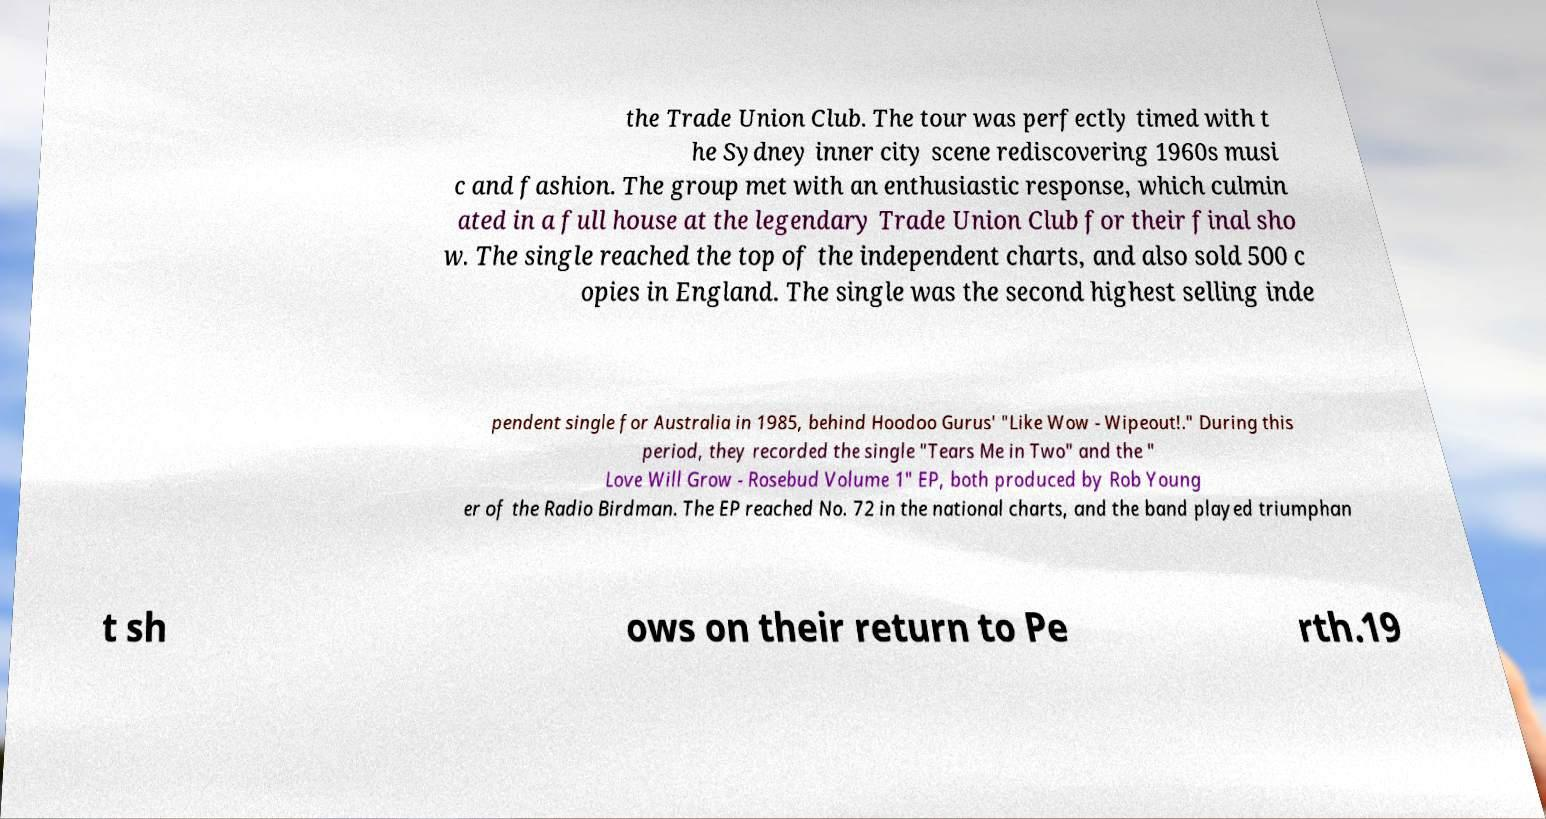Please identify and transcribe the text found in this image. the Trade Union Club. The tour was perfectly timed with t he Sydney inner city scene rediscovering 1960s musi c and fashion. The group met with an enthusiastic response, which culmin ated in a full house at the legendary Trade Union Club for their final sho w. The single reached the top of the independent charts, and also sold 500 c opies in England. The single was the second highest selling inde pendent single for Australia in 1985, behind Hoodoo Gurus' "Like Wow - Wipeout!." During this period, they recorded the single "Tears Me in Two" and the " Love Will Grow - Rosebud Volume 1" EP, both produced by Rob Young er of the Radio Birdman. The EP reached No. 72 in the national charts, and the band played triumphan t sh ows on their return to Pe rth.19 